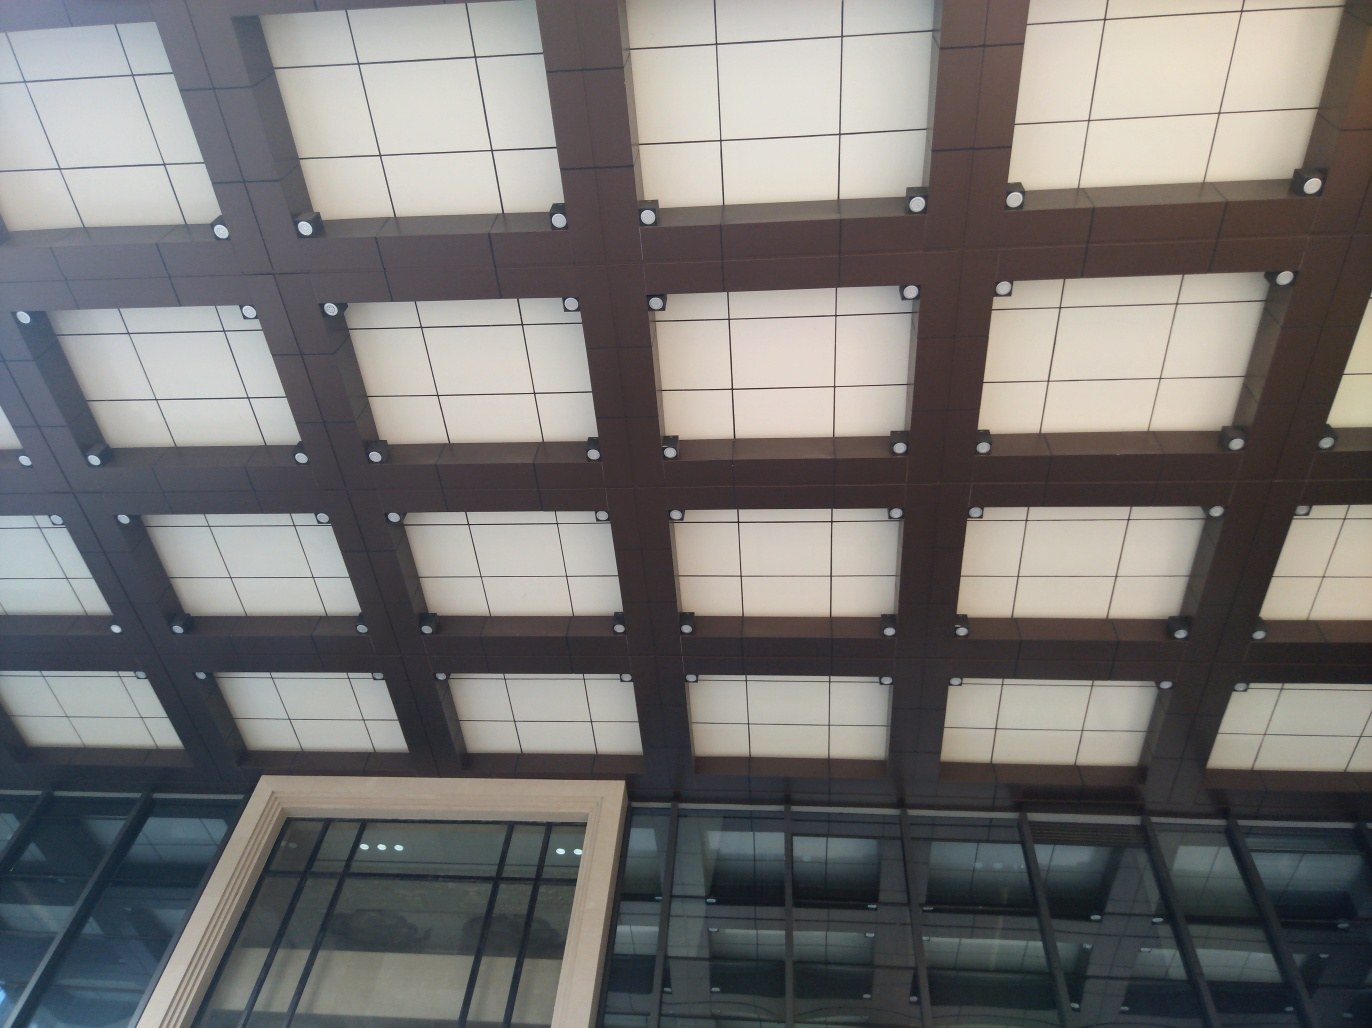What can you infer about the building this ceiling is part of? Based on the ceiling's modern and sophisticated design, it suggests that the building may be a commercial or public space, such as an office building, a gallery, or an airport. The structured and orderly appearance implies a space that values design and aesthetics. 